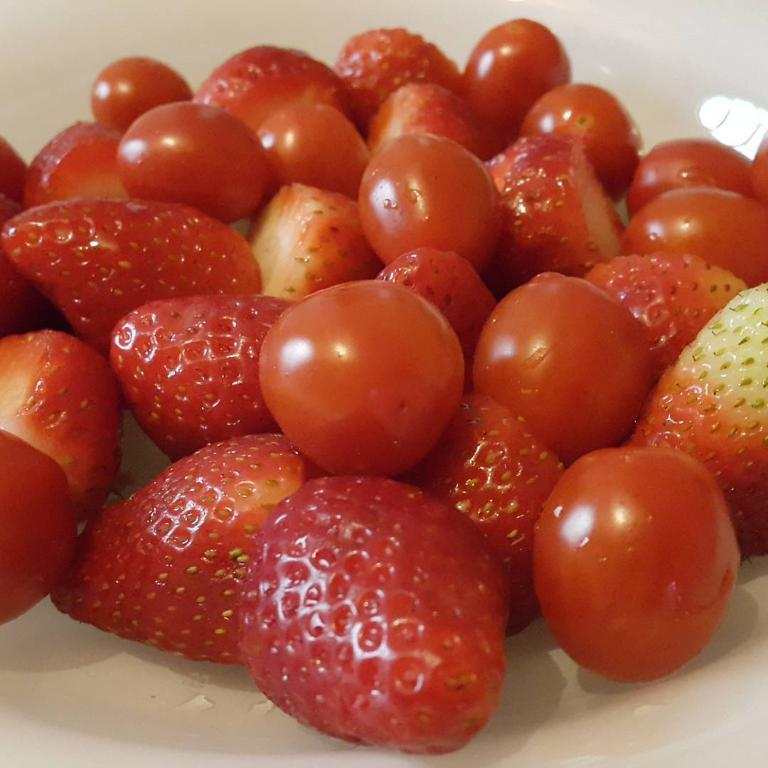What type of fruit can be seen on the plate in the image? There are strawberries and cherries on the plate in the image. What color is the plate? The plate is white. What type of wine is being poured into the glass in the image? There is no glass or wine present in the image; it only features a plate with strawberries and cherries. What type of skirt is the person wearing in the image? There is no person or skirt present in the image; it only features a plate with strawberries and cherries. 